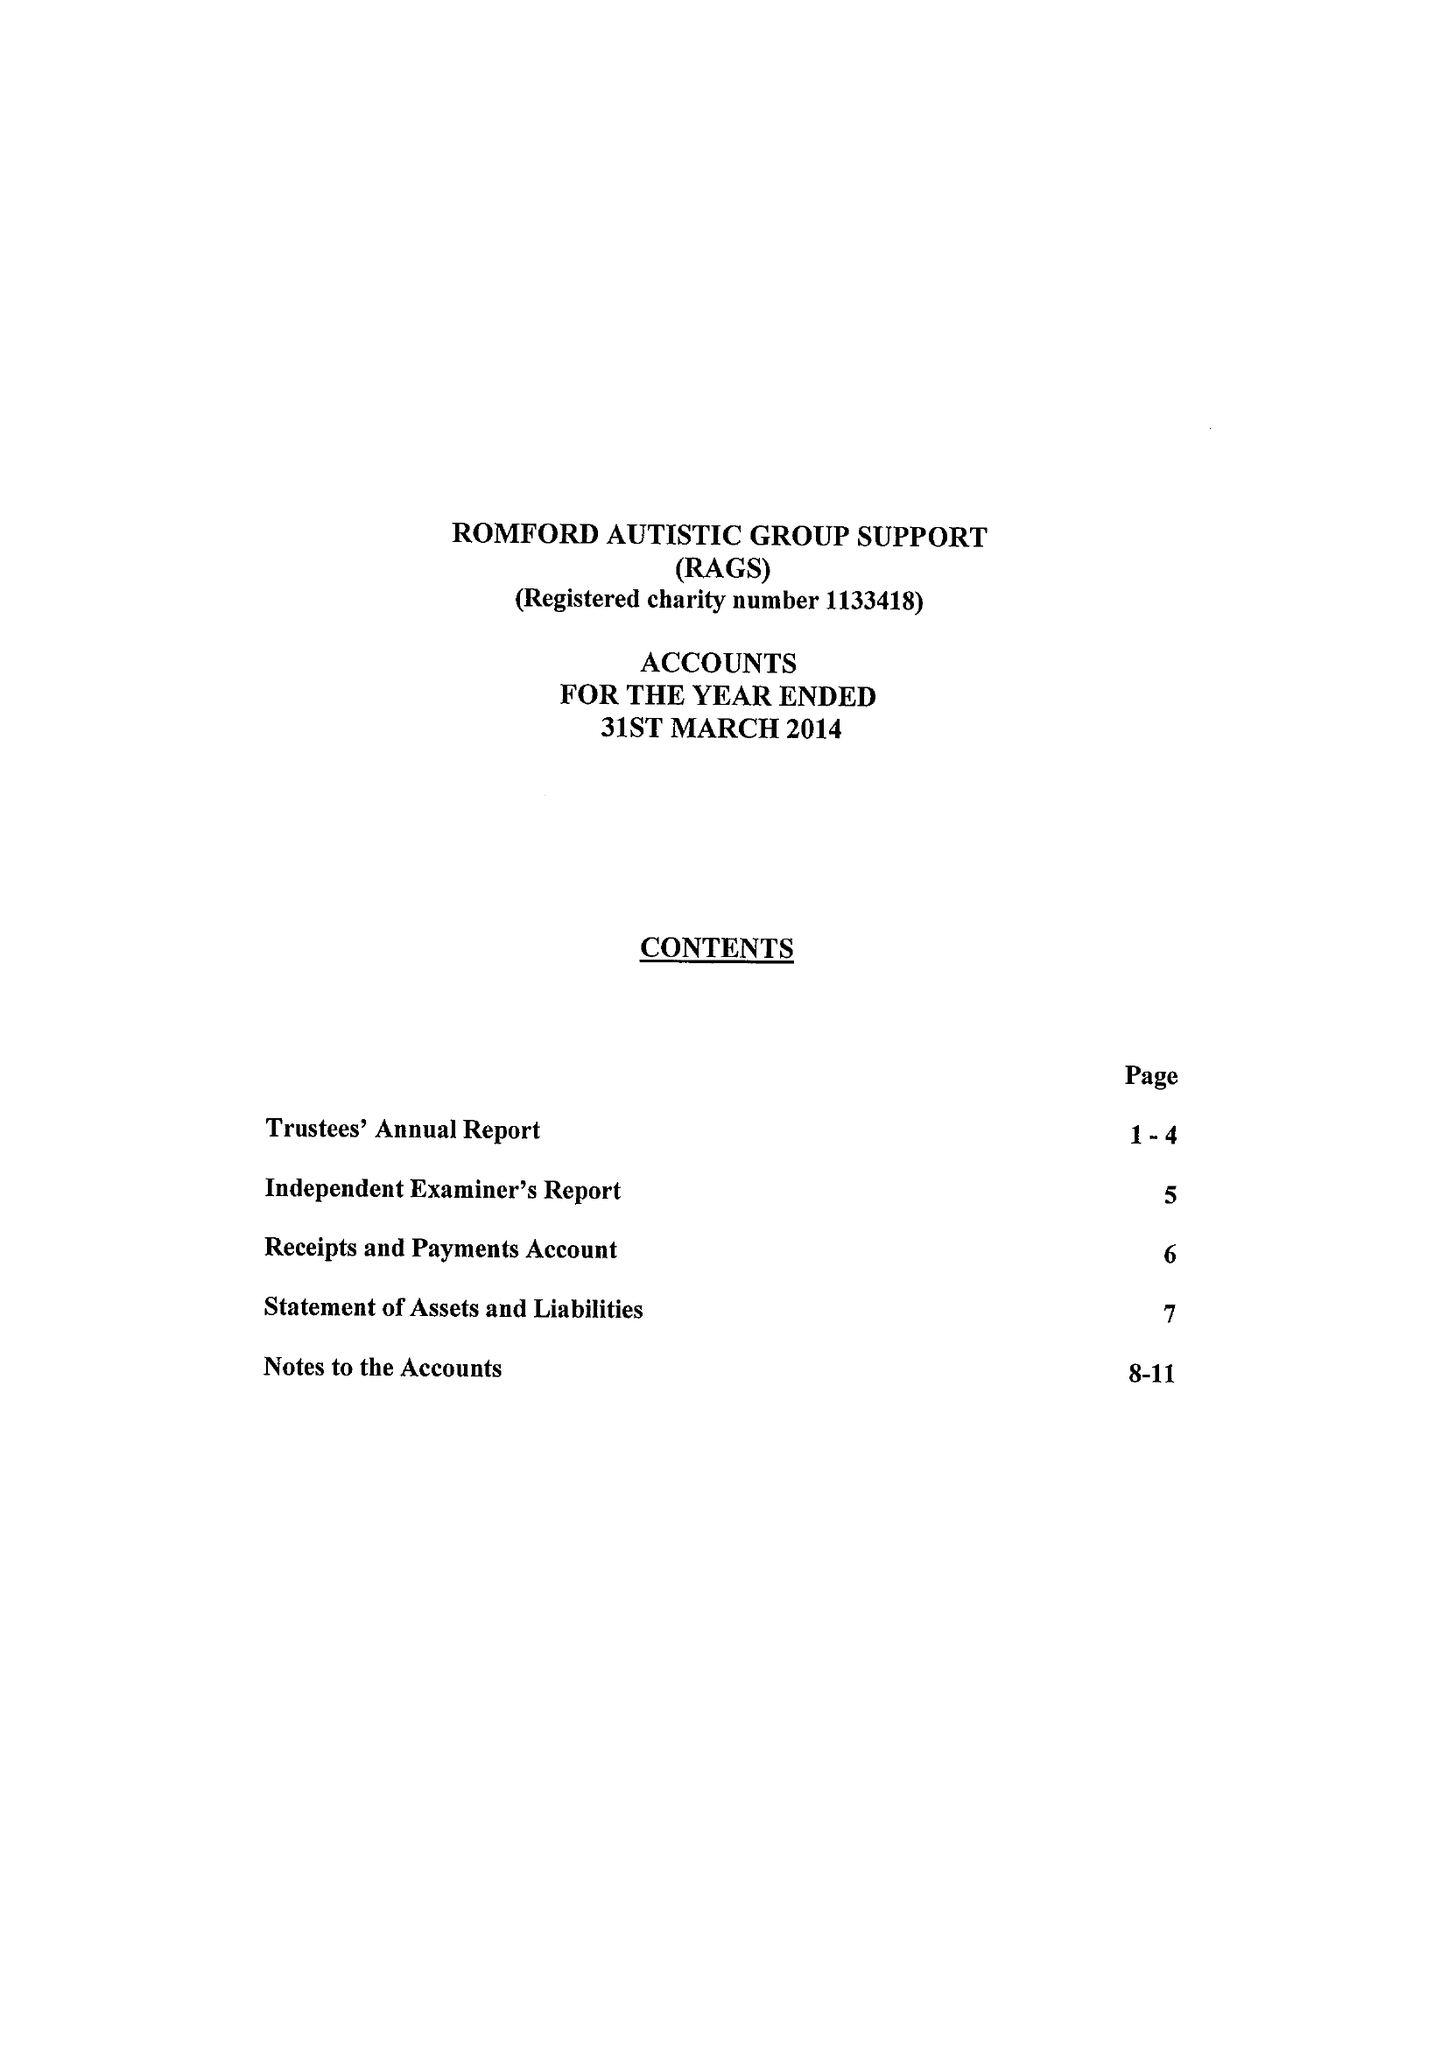What is the value for the spending_annually_in_british_pounds?
Answer the question using a single word or phrase. 93357.00 